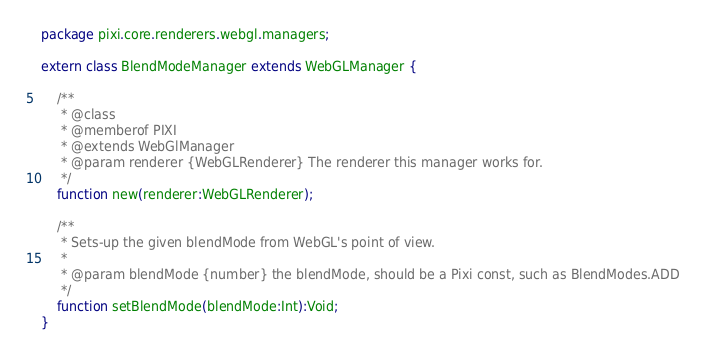<code> <loc_0><loc_0><loc_500><loc_500><_Haxe_>package pixi.core.renderers.webgl.managers;

extern class BlendModeManager extends WebGLManager {

	/**
	 * @class
	 * @memberof PIXI
	 * @extends WebGlManager
	 * @param renderer {WebGLRenderer} The renderer this manager works for.
	 */
	function new(renderer:WebGLRenderer);

	/**
	 * Sets-up the given blendMode from WebGL's point of view.
	 *
	 * @param blendMode {number} the blendMode, should be a Pixi const, such as BlendModes.ADD
	 */
	function setBlendMode(blendMode:Int):Void;
}</code> 